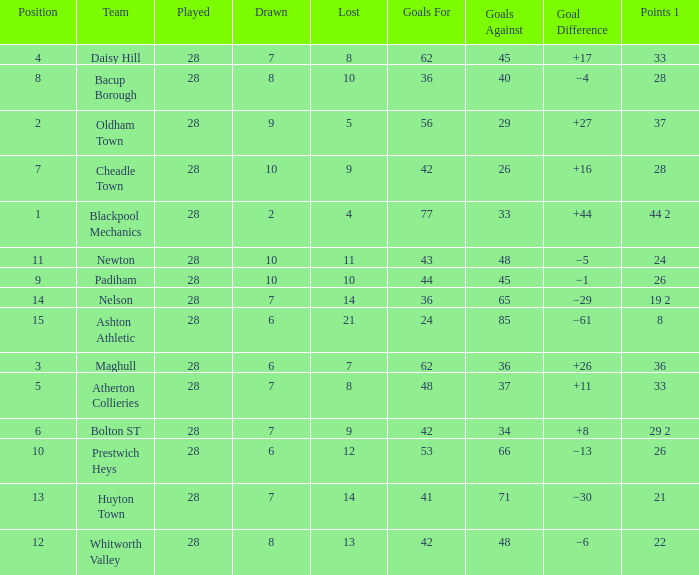What is the lowest drawn for entries with a lost of 13? 8.0. 